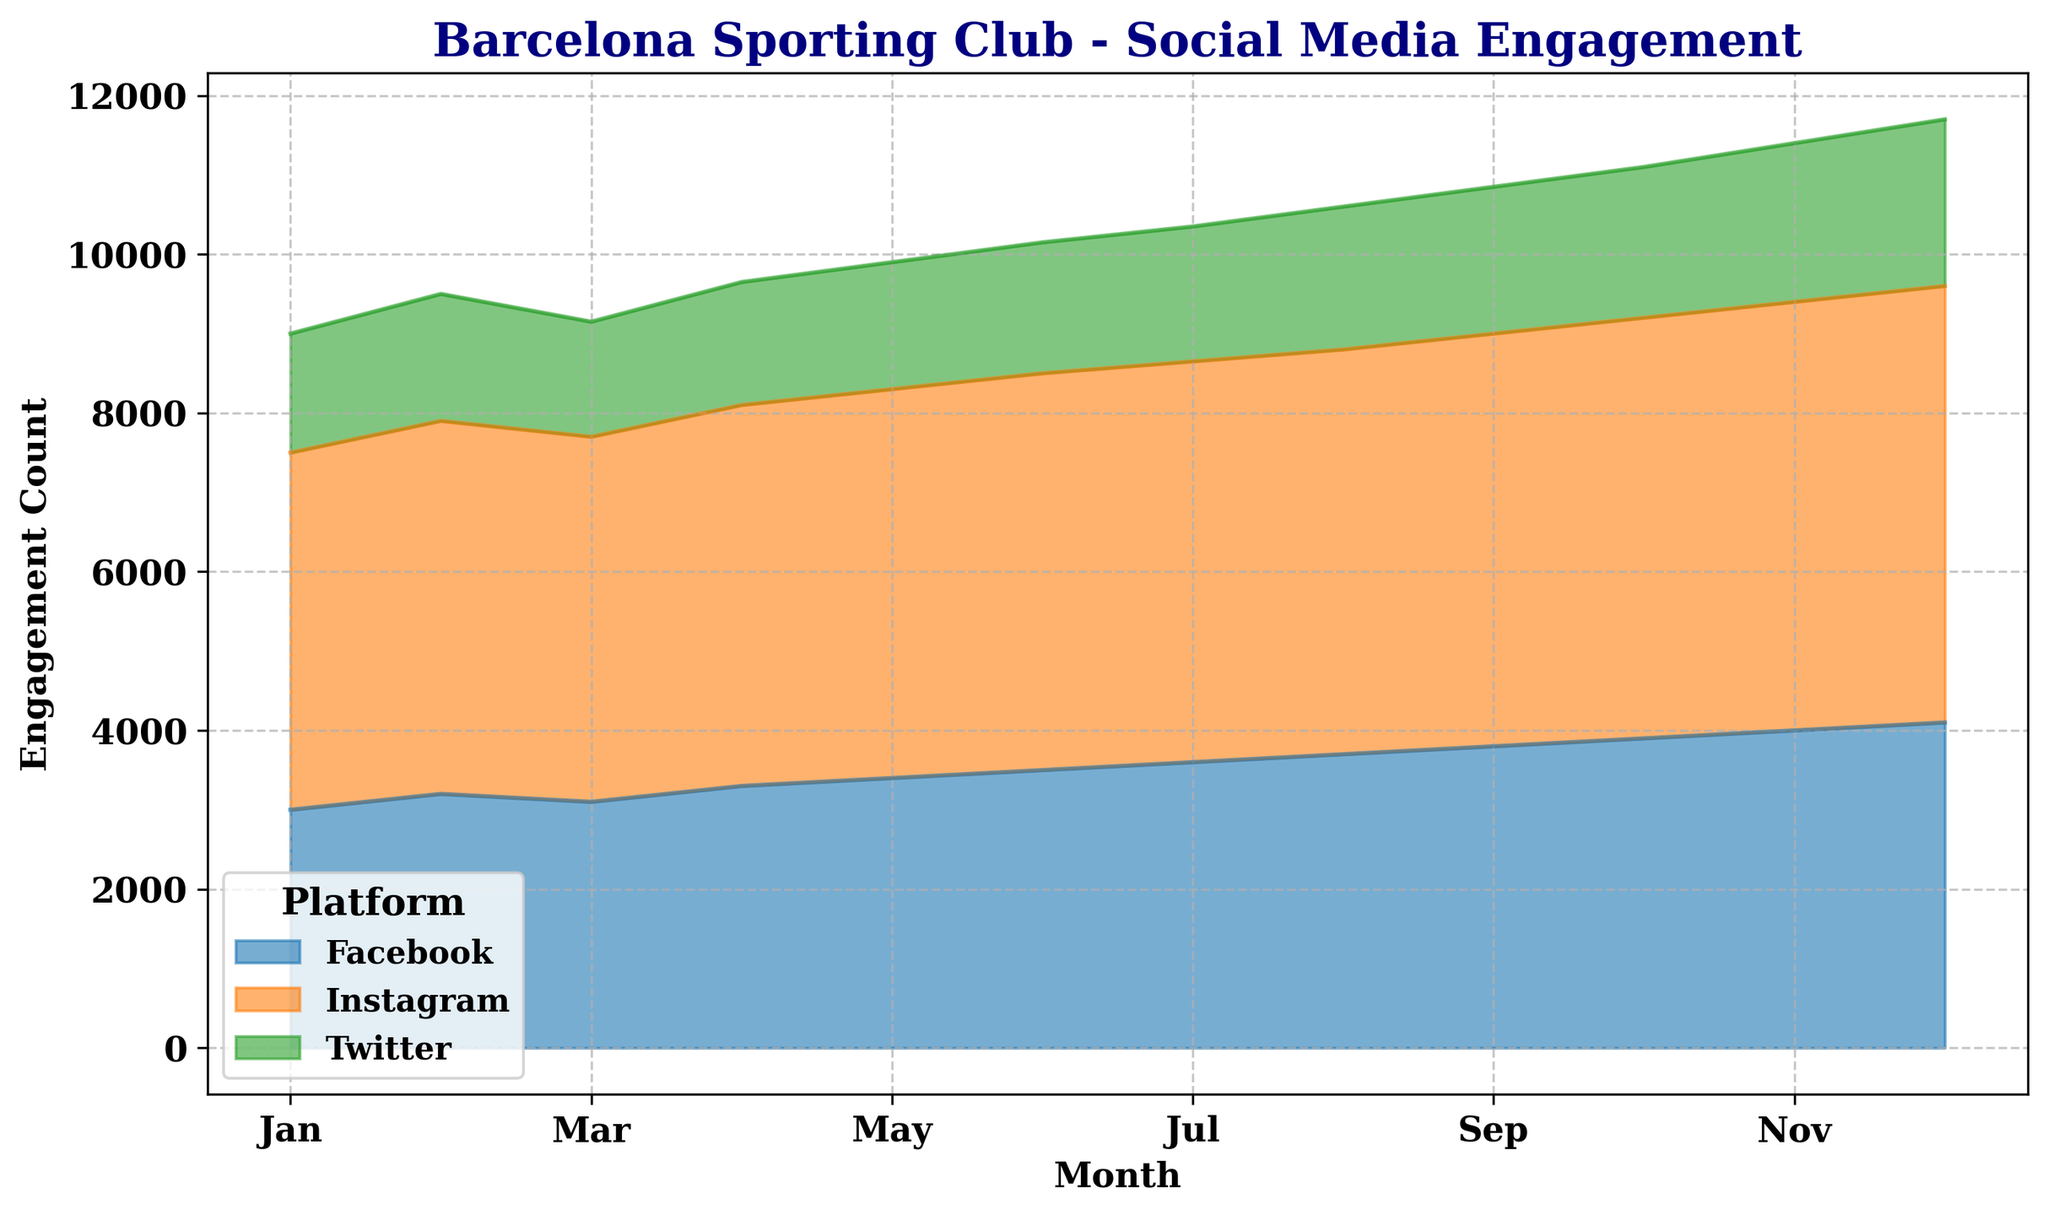What platform had the highest engagement count in December? Looking at the figure for December, the highest area corresponds to Instagram with around 5500 engagement counts.
Answer: Instagram Which month had the lowest total engagement across all platforms? Add the engagement counts for each platform for each month. The month with the lowest sum (Facebook + Twitter + Instagram) will have the lowest total engagement. January has the lowest total engagement count (3000 Facebook + 1500 Twitter + 4500 Instagram = 9000).
Answer: January Between October and November, which month had a higher increase in Facebook engagement? Compare the Facebook engagement count for October (3900) and November (4000). The increase from October to November is 4000 - 3900 = 100.
Answer: November Which platform saw a consistent monthly increase in engagement? By observing the figure, Instagram shows a continual increase every month from January to December.
Answer: Instagram Compute the average engagement count for Twitter across the entire year. Sum up every month's Twitter engagement count and divide by 12. (1500 + 1600 + 1450 + 1550 + 1600 + 1650 + 1700 + 1800 + 1850 + 1900 + 2000 + 2100) / 12 = 18250 / 12 = approximately 1520.83.
Answer: 1520.83 In which month did Facebook surpass 3500 engagement count for the first time? Identify from the figure where Facebook’s engagement area is above the 3500 mark for the first time, which is June at 3500.
Answer: June Which month had the largest increase in Instagram engagement compared to the previous month? Calculate the difference for each month (February - January, March - February, etc.), and the month with the highest positive change will have the largest increase. The highest difference is from November to December (5500 - 5400 = 100).
Answer: December By how much did the total engagement of all platforms increase from January to December? Calculate the total engagement for January and December and find the difference. January: 3000 (Facebook) + 1500 (Twitter) + 4500 (Instagram) = 9000. December: 4100 (Facebook) + 2100 (Twitter) + 5500 (Instagram) = 11700. The increase is 11700 - 9000 = 2700.
Answer: 2700 Which two consecutive months had the smallest change in Facebook engagement? Compute the month-to-month change for Facebook and find the two consecutive months with the smallest value. The smallest change is between February and March (3200 to 3100, a drop of 100).
Answer: February to March 